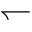<formula> <loc_0><loc_0><loc_500><loc_500>\leftharpoondown</formula> 